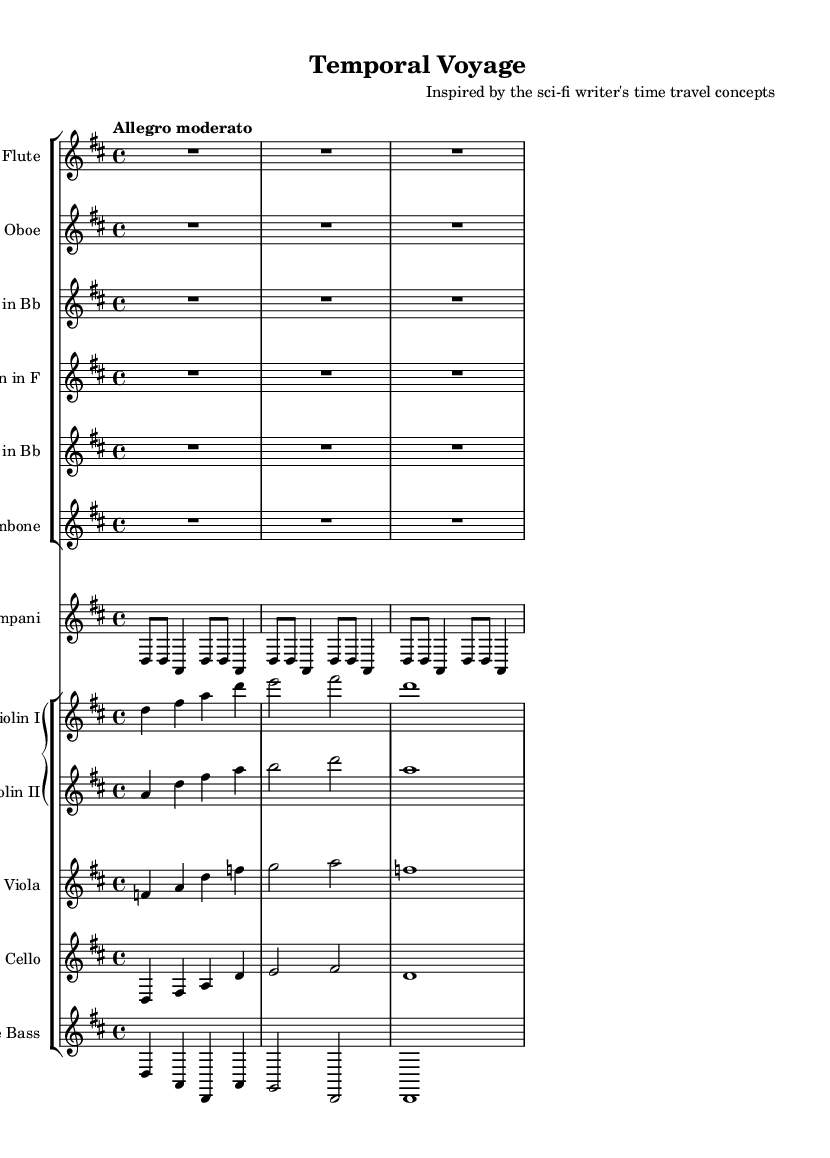What is the key signature of this music? The key signature is indicated at the beginning of the staff lines and shows two sharps, which corresponds to D major.
Answer: D major What is the time signature of this music? The time signature appears at the start and indicates there are four beats in each measure, thus it is 4/4.
Answer: 4/4 What is the tempo marking for the piece? The tempo marking above the staff indicates the speed of the music, which is "Allegro moderato."
Answer: Allegro moderato How many measures are included in the Flute part? The Flute part is indicated with one full measure of rest, so it can be counted as one measure in total.
Answer: 1 What instrument has a part written in bass clef? Looking at the staves, the instrument with the bass clef, which typically indicates lower ranges, is the Cello.
Answer: Cello Which instruments play during the timpani section? The timpani section is indicated by its own staff which shows that only Timpani plays, and no other instruments are shown in that section.
Answer: Timpani What is the highest pitch instrument in this score? The Flute appears at the top of the score, indicating that it plays higher pitches compared to the other instruments listed.
Answer: Flute 